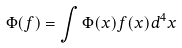Convert formula to latex. <formula><loc_0><loc_0><loc_500><loc_500>\Phi ( f ) = \int \Phi ( x ) f ( x ) d ^ { 4 } x</formula> 